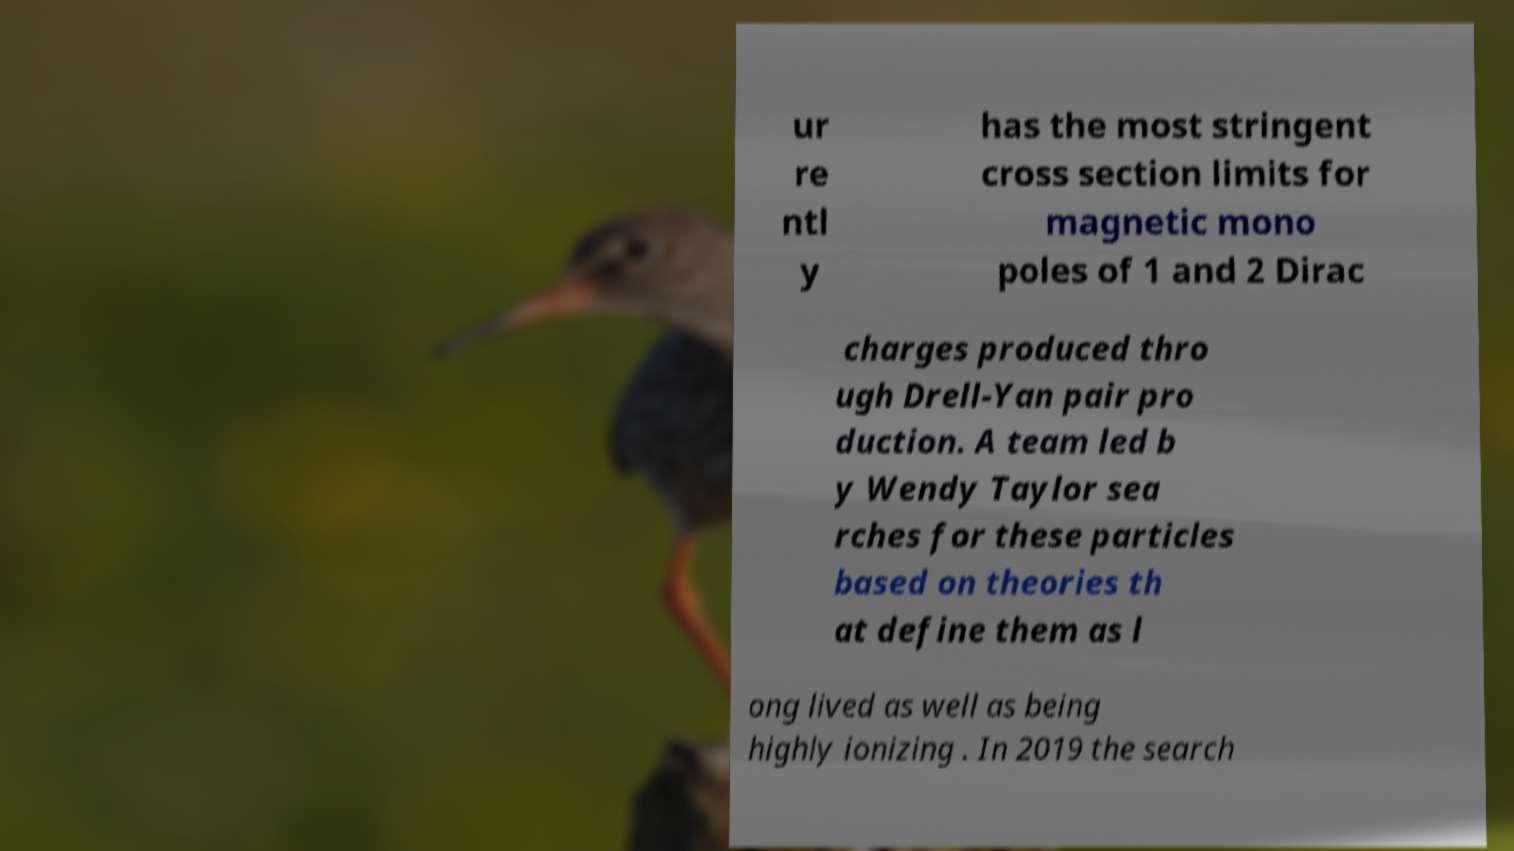Please read and relay the text visible in this image. What does it say? ur re ntl y has the most stringent cross section limits for magnetic mono poles of 1 and 2 Dirac charges produced thro ugh Drell-Yan pair pro duction. A team led b y Wendy Taylor sea rches for these particles based on theories th at define them as l ong lived as well as being highly ionizing . In 2019 the search 